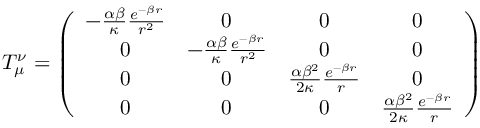<formula> <loc_0><loc_0><loc_500><loc_500>T _ { \mu } ^ { \nu } = \left ( \begin{array} { c c c c } { { - \frac { \alpha \beta } { \kappa } \frac { e ^ { - \beta r } } { r ^ { 2 } } } } & { 0 } & { 0 } & { 0 } \\ { 0 } & { { - \frac { \alpha \beta } { \kappa } \frac { e ^ { - \beta r } } { r ^ { 2 } } } } & { 0 } & { 0 } \\ { 0 } & { 0 } & { { \frac { \alpha \beta ^ { 2 } } { 2 \kappa } \frac { e ^ { - \beta r } } { r } } } & { 0 } \\ { 0 } & { 0 } & { 0 } & { { \frac { \alpha \beta ^ { 2 } } { 2 \kappa } \frac { e ^ { - \beta r } } { r } } } \end{array} \right )</formula> 